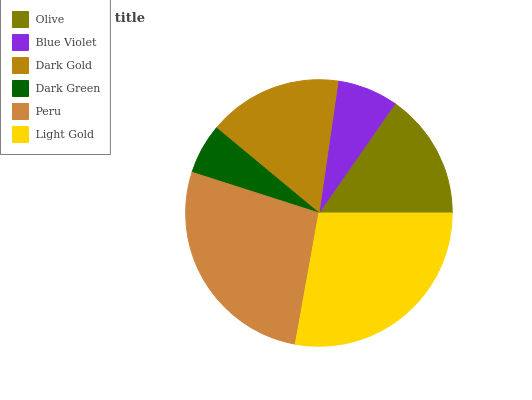Is Dark Green the minimum?
Answer yes or no. Yes. Is Light Gold the maximum?
Answer yes or no. Yes. Is Blue Violet the minimum?
Answer yes or no. No. Is Blue Violet the maximum?
Answer yes or no. No. Is Olive greater than Blue Violet?
Answer yes or no. Yes. Is Blue Violet less than Olive?
Answer yes or no. Yes. Is Blue Violet greater than Olive?
Answer yes or no. No. Is Olive less than Blue Violet?
Answer yes or no. No. Is Dark Gold the high median?
Answer yes or no. Yes. Is Olive the low median?
Answer yes or no. Yes. Is Light Gold the high median?
Answer yes or no. No. Is Dark Gold the low median?
Answer yes or no. No. 